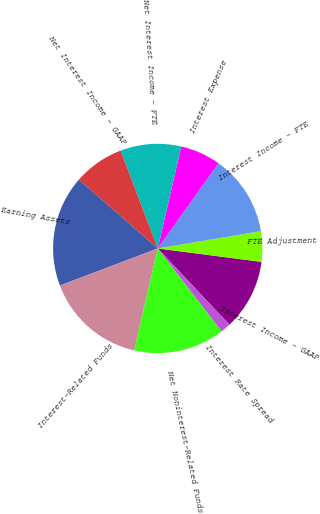Convert chart to OTSL. <chart><loc_0><loc_0><loc_500><loc_500><pie_chart><fcel>Interest Income - GAAP<fcel>FTE Adjustment<fcel>Interest Income - FTE<fcel>Interest Expense<fcel>Net Interest Income - FTE<fcel>Net Interest Income - GAAP<fcel>Earning Assets<fcel>Interest-Related Funds<fcel>Net Noninterest-Related Funds<fcel>Interest Rate Spread<nl><fcel>10.94%<fcel>4.69%<fcel>12.5%<fcel>6.25%<fcel>9.38%<fcel>7.81%<fcel>17.19%<fcel>15.62%<fcel>14.06%<fcel>1.56%<nl></chart> 